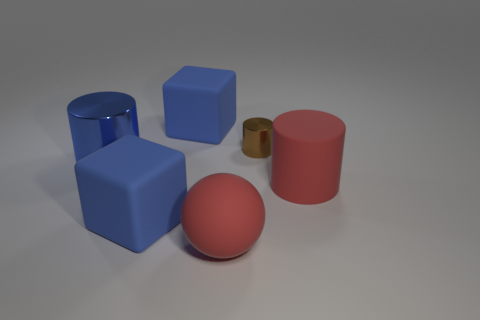Add 3 red rubber objects. How many objects exist? 9 Subtract all cubes. How many objects are left? 4 Add 1 large blue cubes. How many large blue cubes are left? 3 Add 1 matte blocks. How many matte blocks exist? 3 Subtract 0 green spheres. How many objects are left? 6 Subtract all big objects. Subtract all big blue cylinders. How many objects are left? 0 